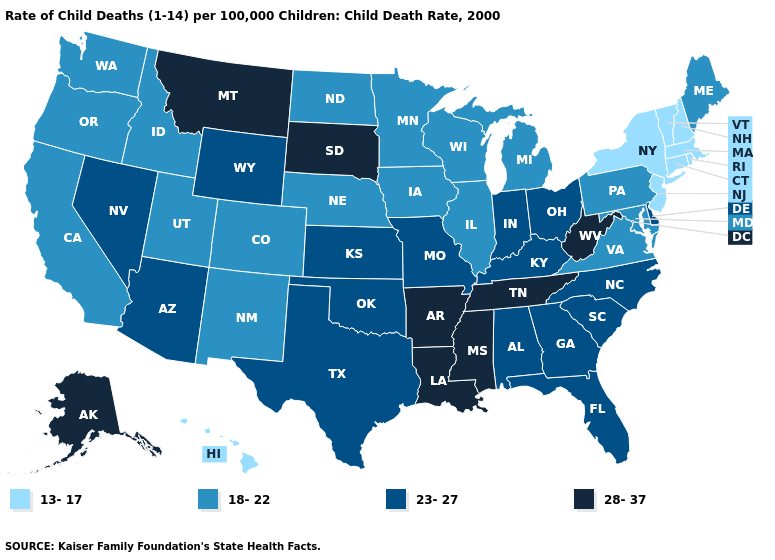Does the map have missing data?
Concise answer only. No. Is the legend a continuous bar?
Answer briefly. No. What is the value of Alabama?
Quick response, please. 23-27. Among the states that border Arkansas , does Mississippi have the lowest value?
Short answer required. No. Name the states that have a value in the range 13-17?
Short answer required. Connecticut, Hawaii, Massachusetts, New Hampshire, New Jersey, New York, Rhode Island, Vermont. How many symbols are there in the legend?
Concise answer only. 4. What is the value of Washington?
Quick response, please. 18-22. Name the states that have a value in the range 13-17?
Be succinct. Connecticut, Hawaii, Massachusetts, New Hampshire, New Jersey, New York, Rhode Island, Vermont. What is the value of Utah?
Give a very brief answer. 18-22. Name the states that have a value in the range 28-37?
Concise answer only. Alaska, Arkansas, Louisiana, Mississippi, Montana, South Dakota, Tennessee, West Virginia. What is the lowest value in the USA?
Be succinct. 13-17. Is the legend a continuous bar?
Concise answer only. No. Which states have the lowest value in the South?
Concise answer only. Maryland, Virginia. Which states have the lowest value in the USA?
Write a very short answer. Connecticut, Hawaii, Massachusetts, New Hampshire, New Jersey, New York, Rhode Island, Vermont. Does Hawaii have a lower value than New York?
Give a very brief answer. No. 